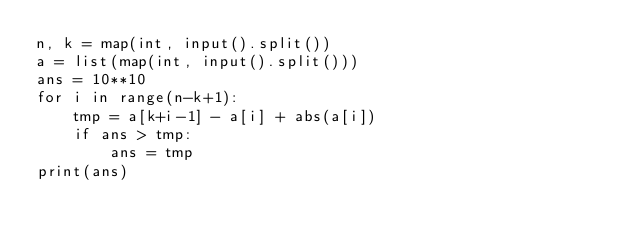<code> <loc_0><loc_0><loc_500><loc_500><_Python_>n, k = map(int, input().split())
a = list(map(int, input().split()))
ans = 10**10
for i in range(n-k+1):
    tmp = a[k+i-1] - a[i] + abs(a[i])
    if ans > tmp:
        ans = tmp
print(ans)</code> 